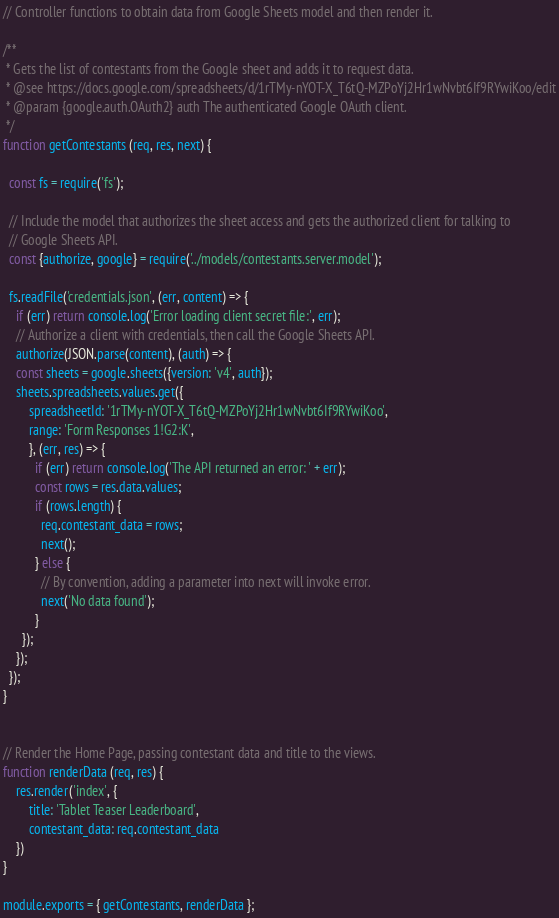<code> <loc_0><loc_0><loc_500><loc_500><_JavaScript_>// Controller functions to obtain data from Google Sheets model and then render it.

/**
 * Gets the list of contestants from the Google sheet and adds it to request data.
 * @see https://docs.google.com/spreadsheets/d/1rTMy-nYOT-X_T6tQ-MZPoYj2Hr1wNvbt6If9RYwiKoo/edit
 * @param {google.auth.OAuth2} auth The authenticated Google OAuth client.
 */
function getContestants (req, res, next) {

  const fs = require('fs');

  // Include the model that authorizes the sheet access and gets the authorized client for talking to
  // Google Sheets API.
  const {authorize, google} = require('../models/contestants.server.model');

  fs.readFile('credentials.json', (err, content) => {
    if (err) return console.log('Error loading client secret file:', err);
    // Authorize a client with credentials, then call the Google Sheets API.
    authorize(JSON.parse(content), (auth) => {
    const sheets = google.sheets({version: 'v4', auth});
    sheets.spreadsheets.values.get({
        spreadsheetId: '1rTMy-nYOT-X_T6tQ-MZPoYj2Hr1wNvbt6If9RYwiKoo',
        range: 'Form Responses 1!G2:K',
        }, (err, res) => {
          if (err) return console.log('The API returned an error: ' + err);
          const rows = res.data.values;
          if (rows.length) {
            req.contestant_data = rows;
            next();
          } else {
            // By convention, adding a parameter into next will invoke error.
            next('No data found');
          }
      });
    });
  });
}


// Render the Home Page, passing contestant data and title to the views.
function renderData (req, res) {
    res.render('index', {
        title: 'Tablet Teaser Leaderboard',
        contestant_data: req.contestant_data
    })
}

module.exports = { getContestants, renderData };
</code> 